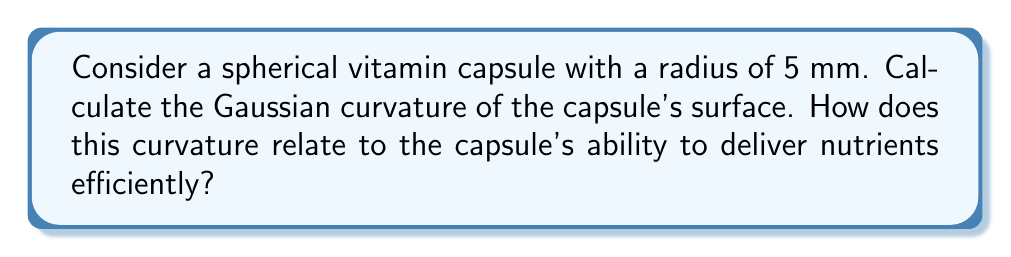Give your solution to this math problem. To solve this problem, we'll follow these steps:

1. Recall the formula for Gaussian curvature of a sphere:
   The Gaussian curvature (K) of a sphere is constant and given by:
   $$K = \frac{1}{R^2}$$
   where R is the radius of the sphere.

2. Insert the given radius:
   R = 5 mm = 5 × 10^-3 m

3. Calculate the Gaussian curvature:
   $$K = \frac{1}{(5 \times 10^{-3})^2} = \frac{1}{25 \times 10^{-6}} = 4 \times 10^4 \text{ m}^{-2}$$

4. Interpretation:
   The constant positive curvature indicates that the surface is uniformly curved in all directions. This spherical shape allows for:
   a) Maximized volume-to-surface area ratio, potentially increasing the amount of nutrients that can be contained.
   b) Smooth passage through the digestive tract, facilitating efficient delivery of nutrients.
   c) Even distribution of the capsule's contents, ensuring consistent dissolution and absorption of nutrients.
Answer: $4 \times 10^4 \text{ m}^{-2}$ 